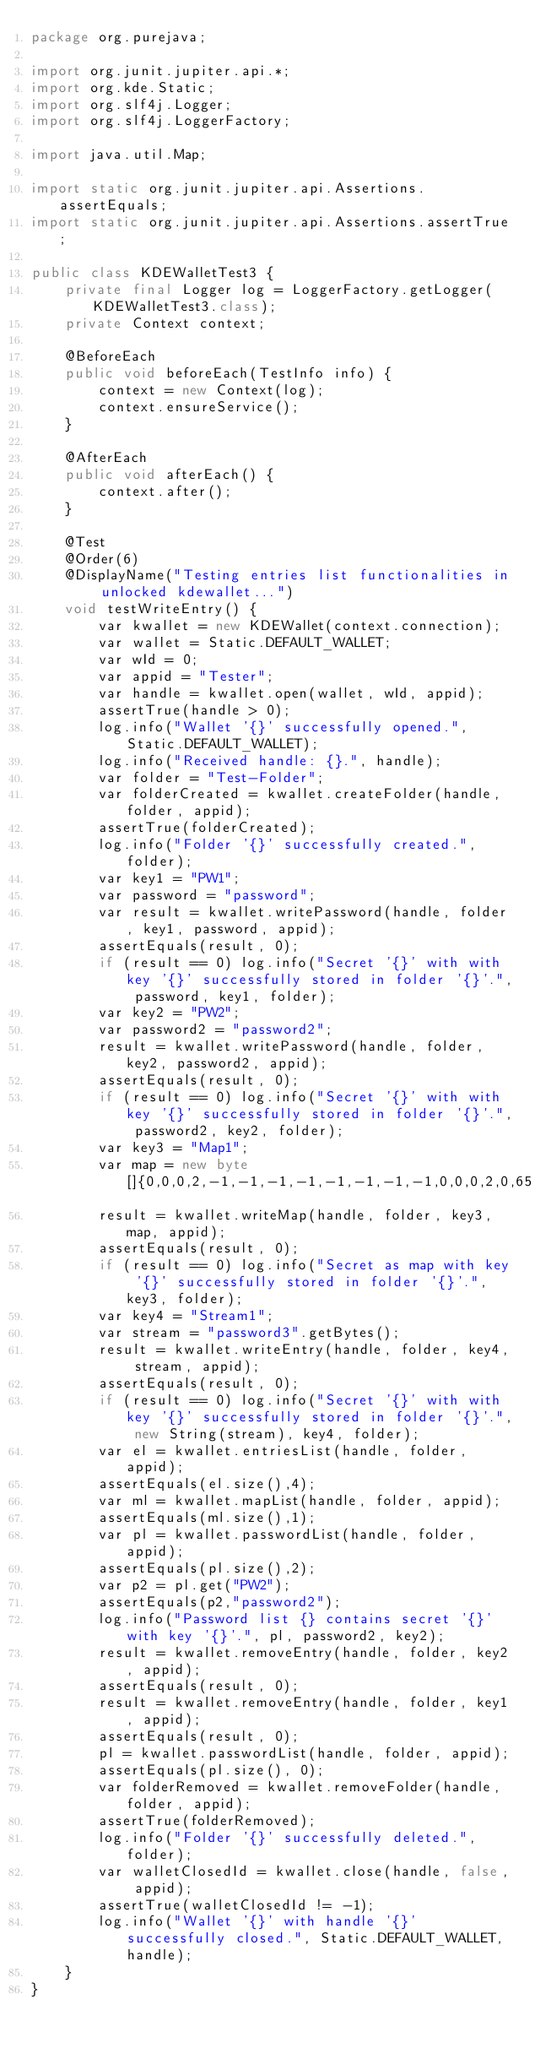<code> <loc_0><loc_0><loc_500><loc_500><_Java_>package org.purejava;

import org.junit.jupiter.api.*;
import org.kde.Static;
import org.slf4j.Logger;
import org.slf4j.LoggerFactory;

import java.util.Map;

import static org.junit.jupiter.api.Assertions.assertEquals;
import static org.junit.jupiter.api.Assertions.assertTrue;

public class KDEWalletTest3 {
    private final Logger log = LoggerFactory.getLogger(KDEWalletTest3.class);
    private Context context;

    @BeforeEach
    public void beforeEach(TestInfo info) {
        context = new Context(log);
        context.ensureService();
    }

    @AfterEach
    public void afterEach() {
        context.after();
    }

    @Test
    @Order(6)
    @DisplayName("Testing entries list functionalities in unlocked kdewallet...")
    void testWriteEntry() {
        var kwallet = new KDEWallet(context.connection);
        var wallet = Static.DEFAULT_WALLET;
        var wId = 0;
        var appid = "Tester";
        var handle = kwallet.open(wallet, wId, appid);
        assertTrue(handle > 0);
        log.info("Wallet '{}' successfully opened.", Static.DEFAULT_WALLET);
        log.info("Received handle: {}.", handle);
        var folder = "Test-Folder";
        var folderCreated = kwallet.createFolder(handle, folder, appid);
        assertTrue(folderCreated);
        log.info("Folder '{}' successfully created.", folder);
        var key1 = "PW1";
        var password = "password";
        var result = kwallet.writePassword(handle, folder, key1, password, appid);
        assertEquals(result, 0);
        if (result == 0) log.info("Secret '{}' with with key '{}' successfully stored in folder '{}'.", password, key1, folder);
        var key2 = "PW2";
        var password2 = "password2";
        result = kwallet.writePassword(handle, folder, key2, password2, appid);
        assertEquals(result, 0);
        if (result == 0) log.info("Secret '{}' with with key '{}' successfully stored in folder '{}'.", password2, key2, folder);
        var key3 = "Map1";
        var map = new byte[]{0,0,0,2,-1,-1,-1,-1,-1,-1,-1,-1,0,0,0,2,0,65,0,0,0,2,0,66};
        result = kwallet.writeMap(handle, folder, key3, map, appid);
        assertEquals(result, 0);
        if (result == 0) log.info("Secret as map with key '{}' successfully stored in folder '{}'.", key3, folder);
        var key4 = "Stream1";
        var stream = "password3".getBytes();
        result = kwallet.writeEntry(handle, folder, key4, stream, appid);
        assertEquals(result, 0);
        if (result == 0) log.info("Secret '{}' with with key '{}' successfully stored in folder '{}'.", new String(stream), key4, folder);
        var el = kwallet.entriesList(handle, folder, appid);
        assertEquals(el.size(),4);
        var ml = kwallet.mapList(handle, folder, appid);
        assertEquals(ml.size(),1);
        var pl = kwallet.passwordList(handle, folder, appid);
        assertEquals(pl.size(),2);
        var p2 = pl.get("PW2");
        assertEquals(p2,"password2");
        log.info("Password list {} contains secret '{}' with key '{}'.", pl, password2, key2);
        result = kwallet.removeEntry(handle, folder, key2, appid);
        assertEquals(result, 0);
        result = kwallet.removeEntry(handle, folder, key1, appid);
        assertEquals(result, 0);
        pl = kwallet.passwordList(handle, folder, appid);
        assertEquals(pl.size(), 0);
        var folderRemoved = kwallet.removeFolder(handle, folder, appid);
        assertTrue(folderRemoved);
        log.info("Folder '{}' successfully deleted.", folder);
        var walletClosedId = kwallet.close(handle, false, appid);
        assertTrue(walletClosedId != -1);
        log.info("Wallet '{}' with handle '{}' successfully closed.", Static.DEFAULT_WALLET, handle);
    }
}
</code> 